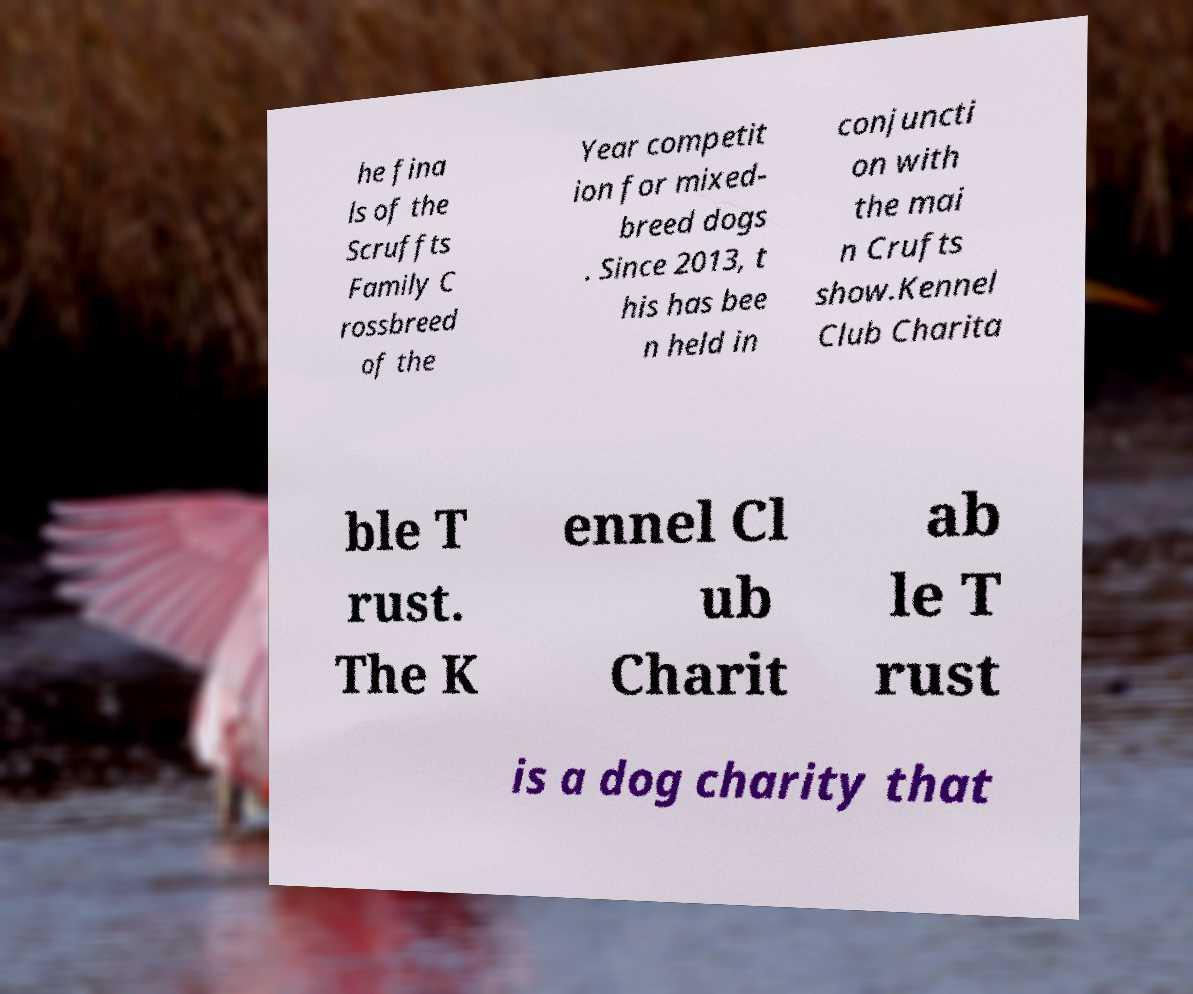There's text embedded in this image that I need extracted. Can you transcribe it verbatim? he fina ls of the Scruffts Family C rossbreed of the Year competit ion for mixed- breed dogs . Since 2013, t his has bee n held in conjuncti on with the mai n Crufts show.Kennel Club Charita ble T rust. The K ennel Cl ub Charit ab le T rust is a dog charity that 